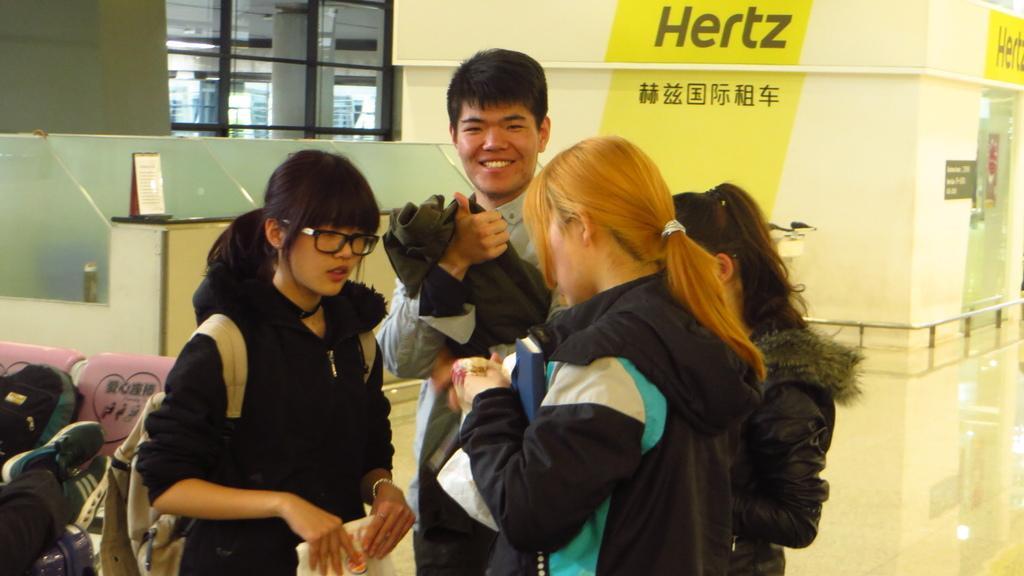Could you give a brief overview of what you see in this image? In this image there are four persons standing, a person smiling, and in the background there is a board, pair of shoes, bag , chairs. 